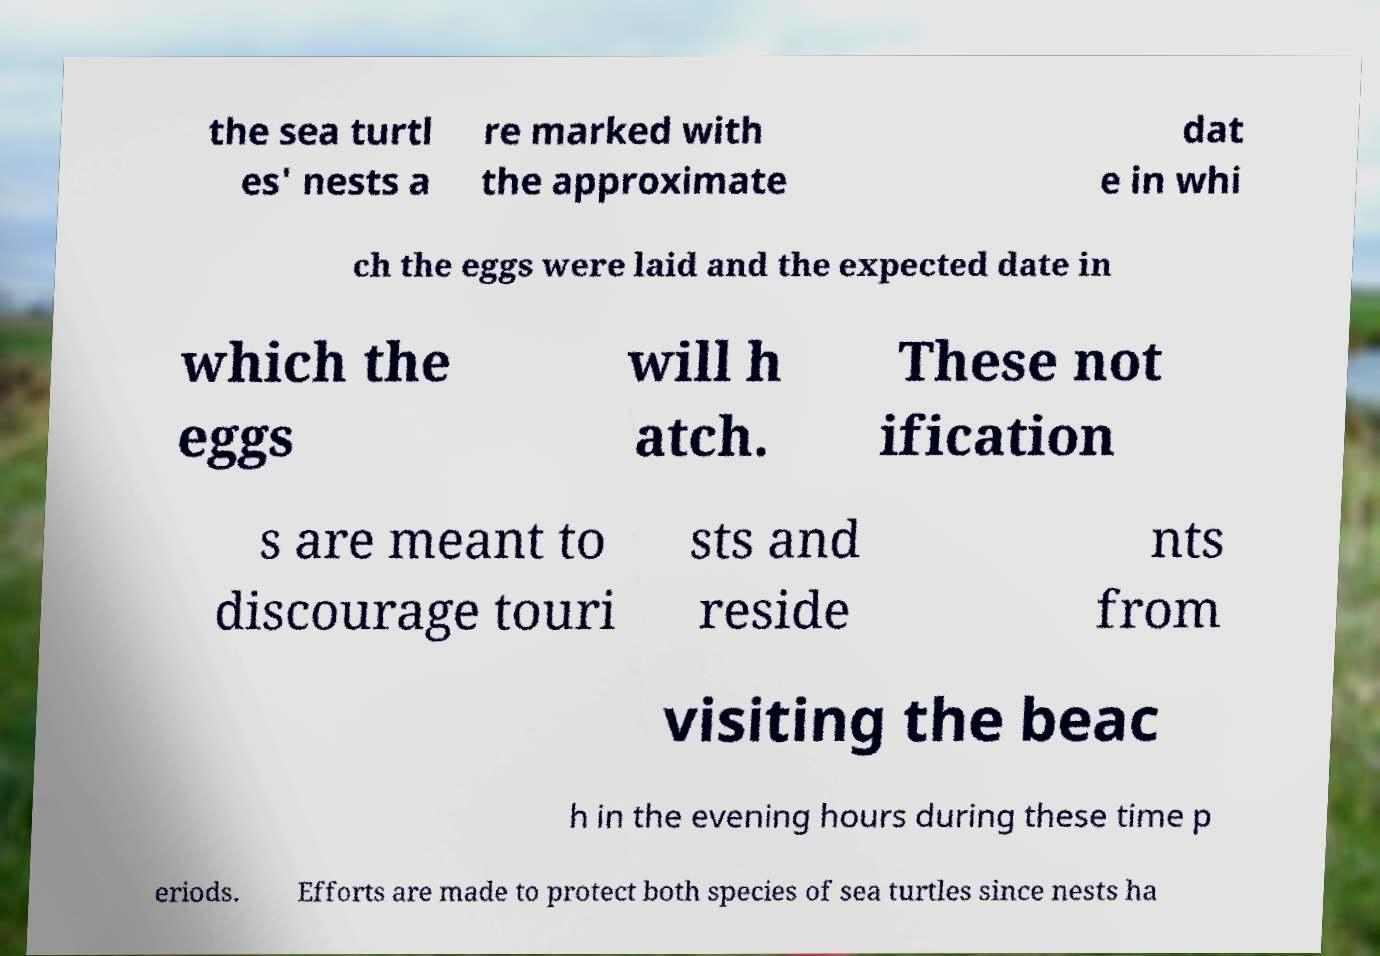Could you assist in decoding the text presented in this image and type it out clearly? the sea turtl es' nests a re marked with the approximate dat e in whi ch the eggs were laid and the expected date in which the eggs will h atch. These not ification s are meant to discourage touri sts and reside nts from visiting the beac h in the evening hours during these time p eriods. Efforts are made to protect both species of sea turtles since nests ha 